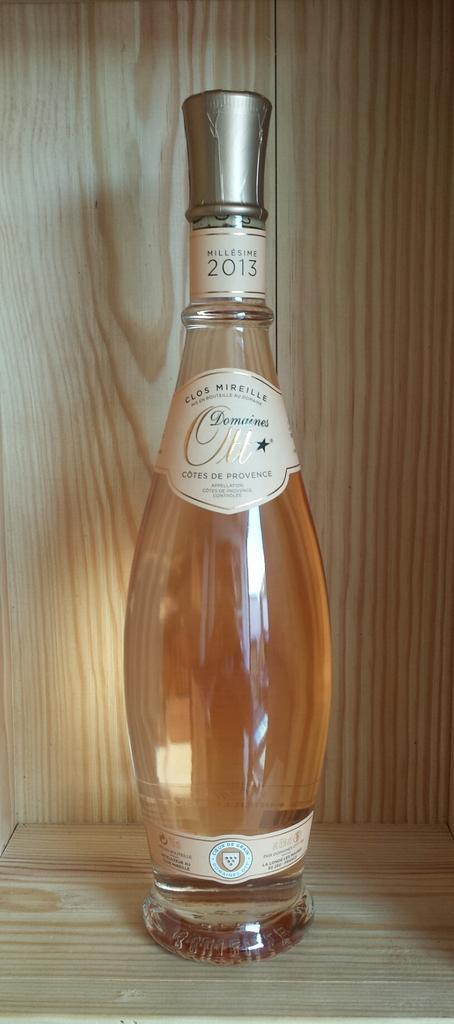In one or two sentences, can you explain what this image depicts? In this picture there is a wine bottle, kept in wooden shelf there are some labels on it and there is a knob given on it 